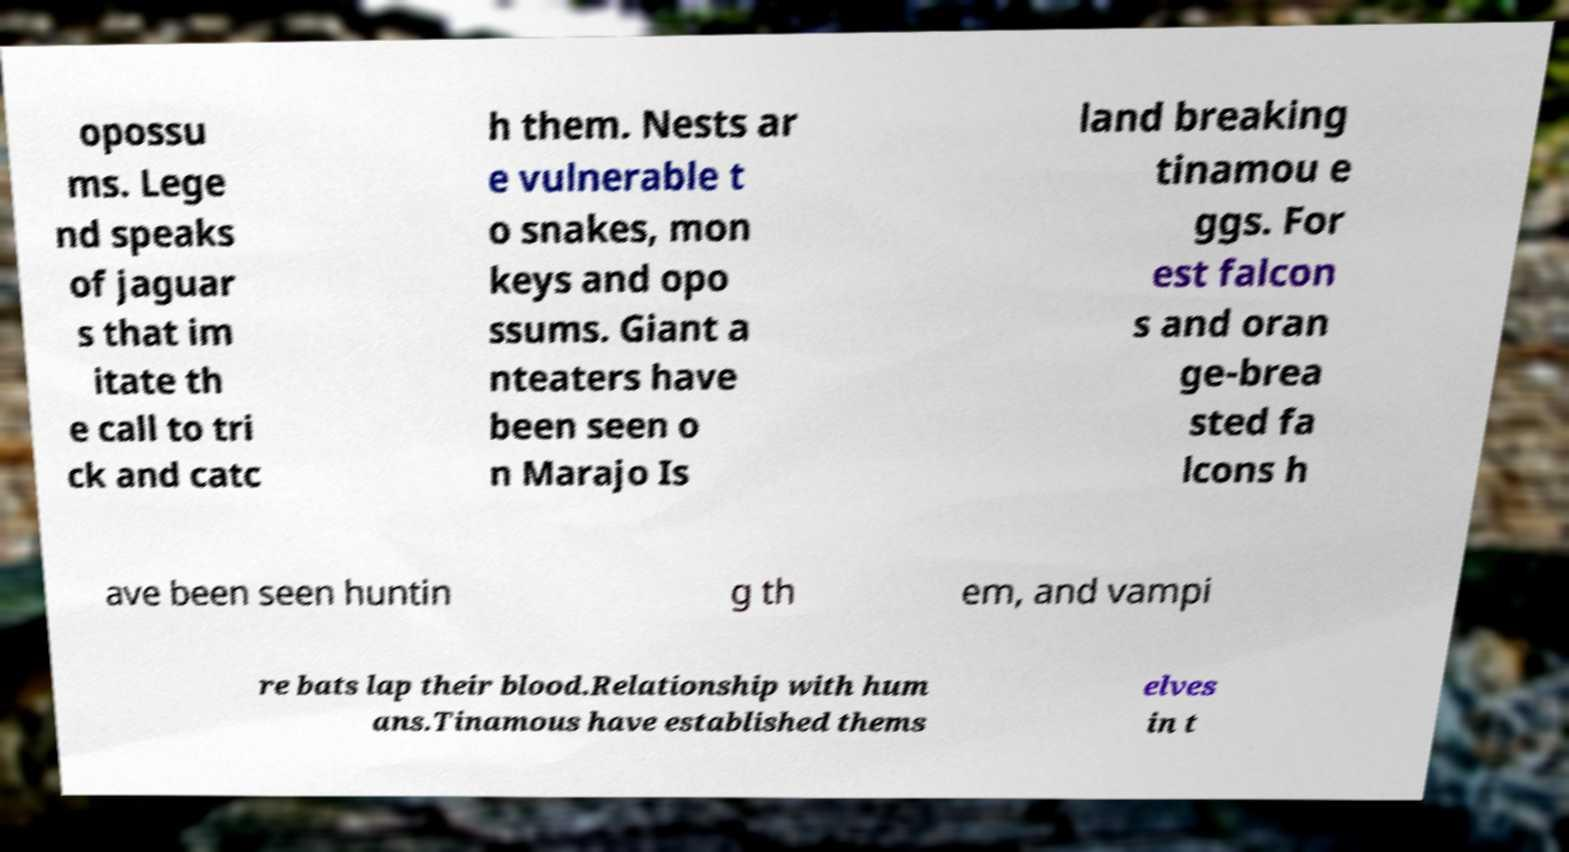I need the written content from this picture converted into text. Can you do that? opossu ms. Lege nd speaks of jaguar s that im itate th e call to tri ck and catc h them. Nests ar e vulnerable t o snakes, mon keys and opo ssums. Giant a nteaters have been seen o n Marajo Is land breaking tinamou e ggs. For est falcon s and oran ge-brea sted fa lcons h ave been seen huntin g th em, and vampi re bats lap their blood.Relationship with hum ans.Tinamous have established thems elves in t 